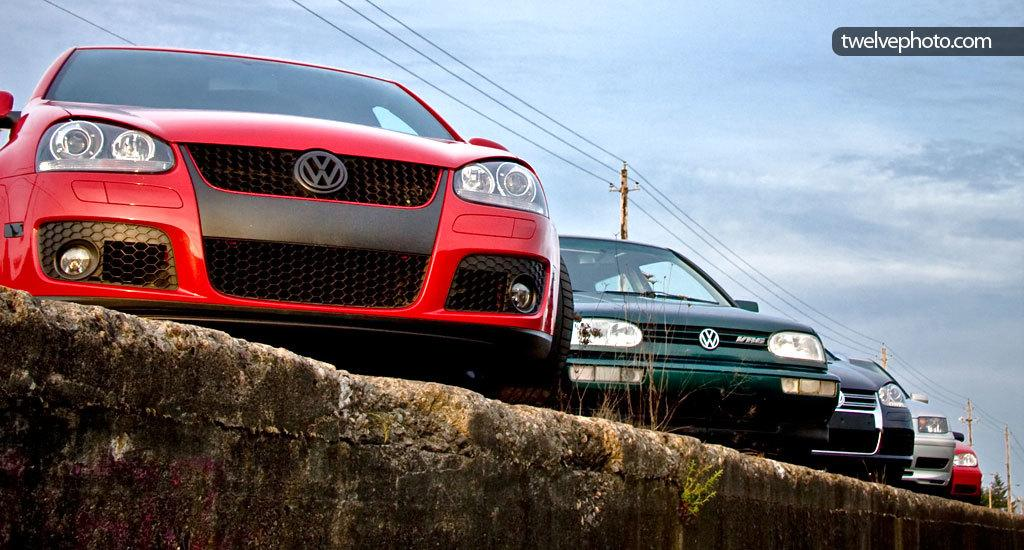What type of vehicles can be seen in the image? There are cars in the image. What other objects are present in the image besides cars? There are poles in the image. How would you describe the weather based on the image? The sky is cloudy in the image, suggesting a potentially overcast or cloudy day. Is there any text visible in the image? Yes, there is text in the top right corner of the image. Can you see any goldfish swimming in the image? There are no goldfish present in the image. Is there a writer visible in the image? There is no writer present in the image. 